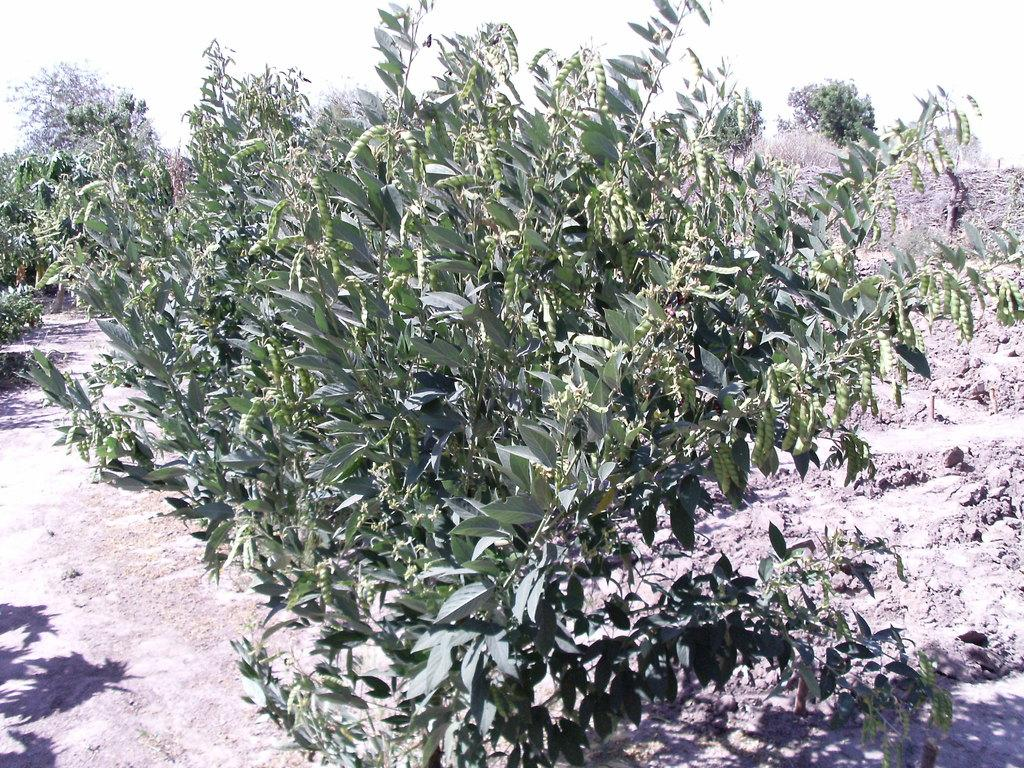Where was the image taken? The image is taken outdoors. What can be seen at the bottom of the image? There is a ground visible at the bottom of the image. What type of vegetation is present in the image? There are trees with green leaves, stems, and branches in the middle of the image. What type of quill can be seen in the image? There is no quill present in the image. How does the throat of the tree look in the image? Trees do not have throats; the question is not applicable to the image. 